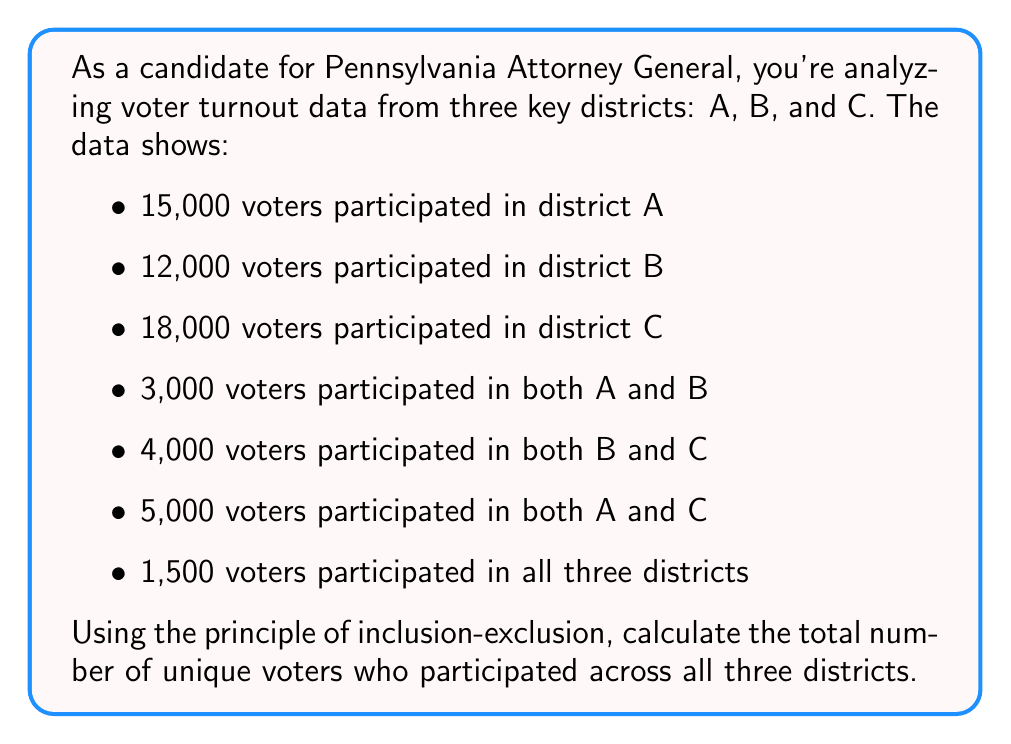Help me with this question. To solve this problem, we'll use the principle of inclusion-exclusion for three sets. Let's define our sets:

$A$: voters in district A
$B$: voters in district B
$C$: voters in district C

The formula for the union of three sets is:

$$|A \cup B \cup C| = |A| + |B| + |C| - |A \cap B| - |B \cap C| - |A \cap C| + |A \cap B \cap C|$$

Let's substitute the given values:

$|A| = 15,000$
$|B| = 12,000$
$|C| = 18,000$
$|A \cap B| = 3,000$
$|B \cap C| = 4,000$
$|A \cap C| = 5,000$
$|A \cap B \cap C| = 1,500$

Now, let's calculate:

$$\begin{align*}
|A \cup B \cup C| &= 15,000 + 12,000 + 18,000 - 3,000 - 4,000 - 5,000 + 1,500 \\
&= 45,000 - 12,000 + 1,500 \\
&= 34,500
\end{align*}$$

Therefore, the total number of unique voters who participated across all three districts is 34,500.
Answer: 34,500 unique voters 